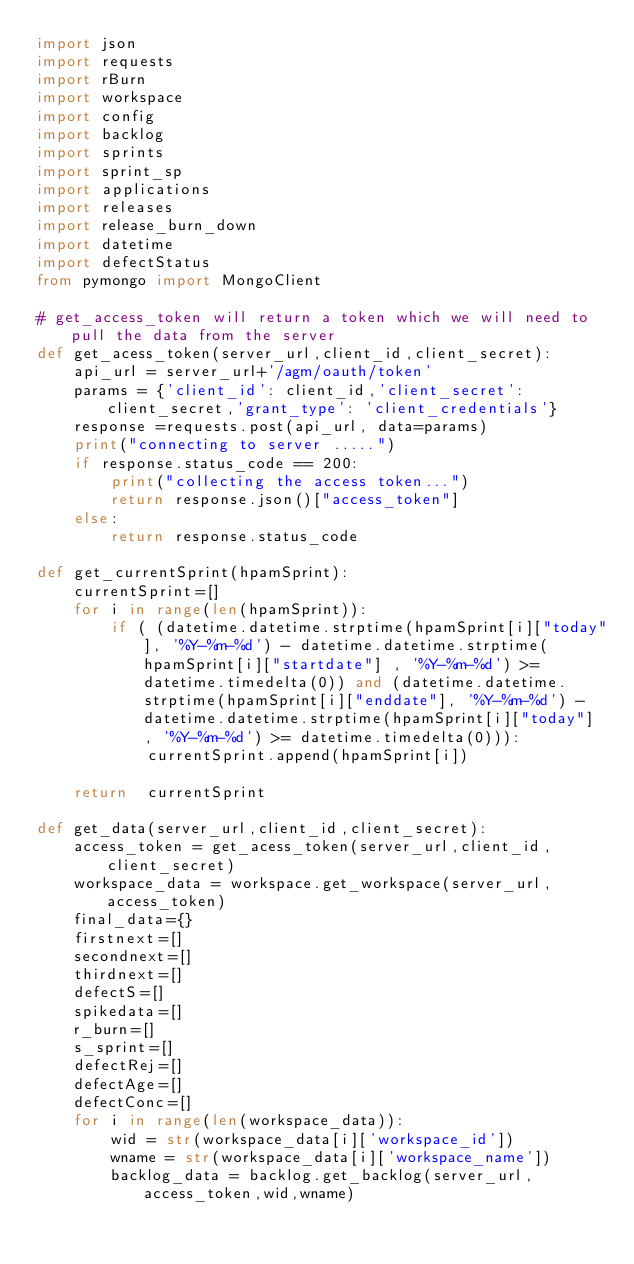<code> <loc_0><loc_0><loc_500><loc_500><_Python_>import json
import requests
import rBurn
import workspace
import config
import backlog
import sprints
import sprint_sp
import applications
import releases
import release_burn_down
import datetime
import defectStatus
from pymongo import MongoClient

# get_access_token will return a token which we will need to pull the data from the server
def get_acess_token(server_url,client_id,client_secret):
	api_url = server_url+'/agm/oauth/token'
	params = {'client_id': client_id,'client_secret': client_secret,'grant_type': 'client_credentials'}
	response =requests.post(api_url, data=params)
	print("connecting to server .....")
	if response.status_code == 200:
		print("collecting the access token...")
		return response.json()["access_token"]
	else:
		return response.status_code
		
def get_currentSprint(hpamSprint):
	currentSprint=[]
	for i in range(len(hpamSprint)):
		if ( (datetime.datetime.strptime(hpamSprint[i]["today"], '%Y-%m-%d') - datetime.datetime.strptime(hpamSprint[i]["startdate"] , '%Y-%m-%d') >= datetime.timedelta(0)) and (datetime.datetime.strptime(hpamSprint[i]["enddate"], '%Y-%m-%d') - datetime.datetime.strptime(hpamSprint[i]["today"] , '%Y-%m-%d') >= datetime.timedelta(0))):
			currentSprint.append(hpamSprint[i])

	return  currentSprint

def get_data(server_url,client_id,client_secret):
	access_token = get_acess_token(server_url,client_id,client_secret)
	workspace_data = workspace.get_workspace(server_url, access_token)
	final_data={}
	firstnext=[]
	secondnext=[]
	thirdnext=[]
	defectS=[]
	spikedata=[]
	r_burn=[]
	s_sprint=[]
	defectRej=[]
	defectAge=[]
	defectConc=[]
	for i in range(len(workspace_data)):
		wid = str(workspace_data[i]['workspace_id'])
		wname = str(workspace_data[i]['workspace_name'])
		backlog_data = backlog.get_backlog(server_url, access_token,wid,wname)</code> 